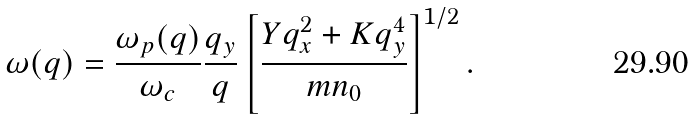<formula> <loc_0><loc_0><loc_500><loc_500>\omega ( { q } ) = \frac { \omega _ { p } ( q ) } { \omega _ { c } } \frac { q _ { y } } { q } \left [ \frac { Y q _ { x } ^ { 2 } + K q _ { y } ^ { 4 } } { m n _ { 0 } } \right ] ^ { 1 / 2 } .</formula> 